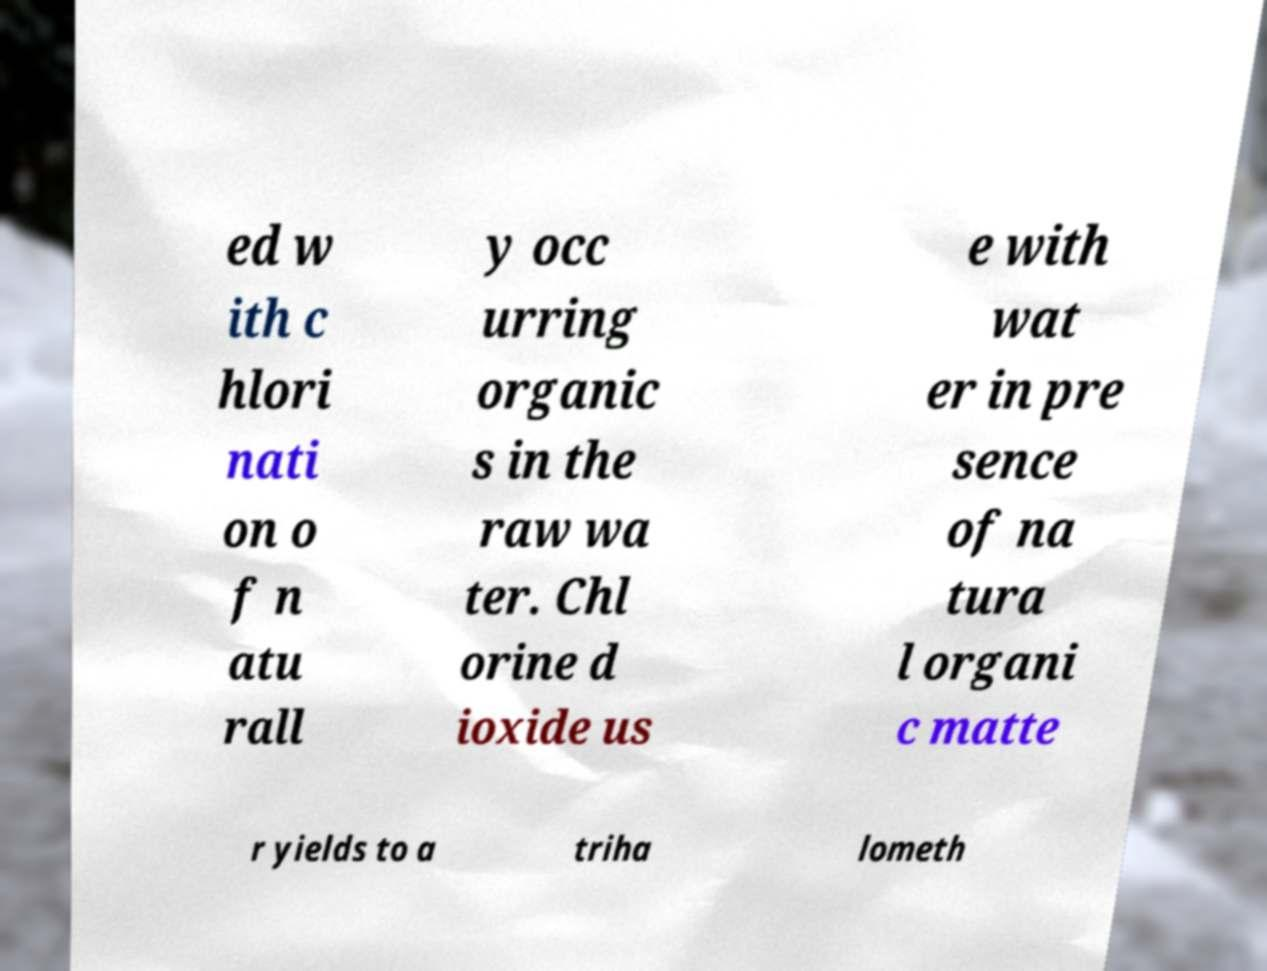Could you assist in decoding the text presented in this image and type it out clearly? ed w ith c hlori nati on o f n atu rall y occ urring organic s in the raw wa ter. Chl orine d ioxide us e with wat er in pre sence of na tura l organi c matte r yields to a triha lometh 